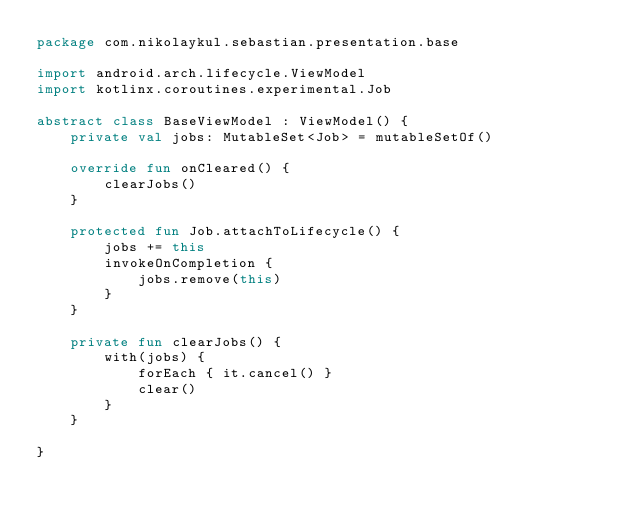<code> <loc_0><loc_0><loc_500><loc_500><_Kotlin_>package com.nikolaykul.sebastian.presentation.base

import android.arch.lifecycle.ViewModel
import kotlinx.coroutines.experimental.Job

abstract class BaseViewModel : ViewModel() {
    private val jobs: MutableSet<Job> = mutableSetOf()

    override fun onCleared() {
        clearJobs()
    }

    protected fun Job.attachToLifecycle() {
        jobs += this
        invokeOnCompletion {
            jobs.remove(this)
        }
    }

    private fun clearJobs() {
        with(jobs) {
            forEach { it.cancel() }
            clear()
        }
    }

}</code> 